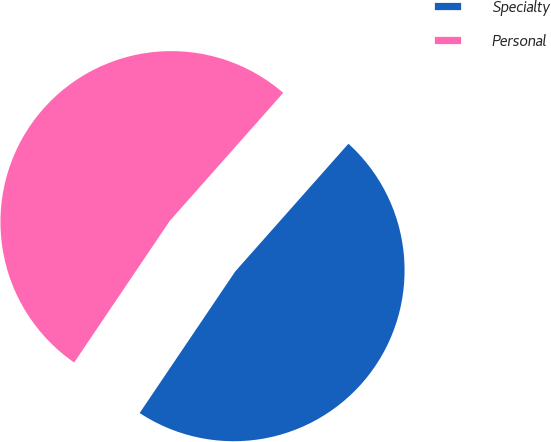Convert chart. <chart><loc_0><loc_0><loc_500><loc_500><pie_chart><fcel>Specialty<fcel>Personal<nl><fcel>47.91%<fcel>52.09%<nl></chart> 